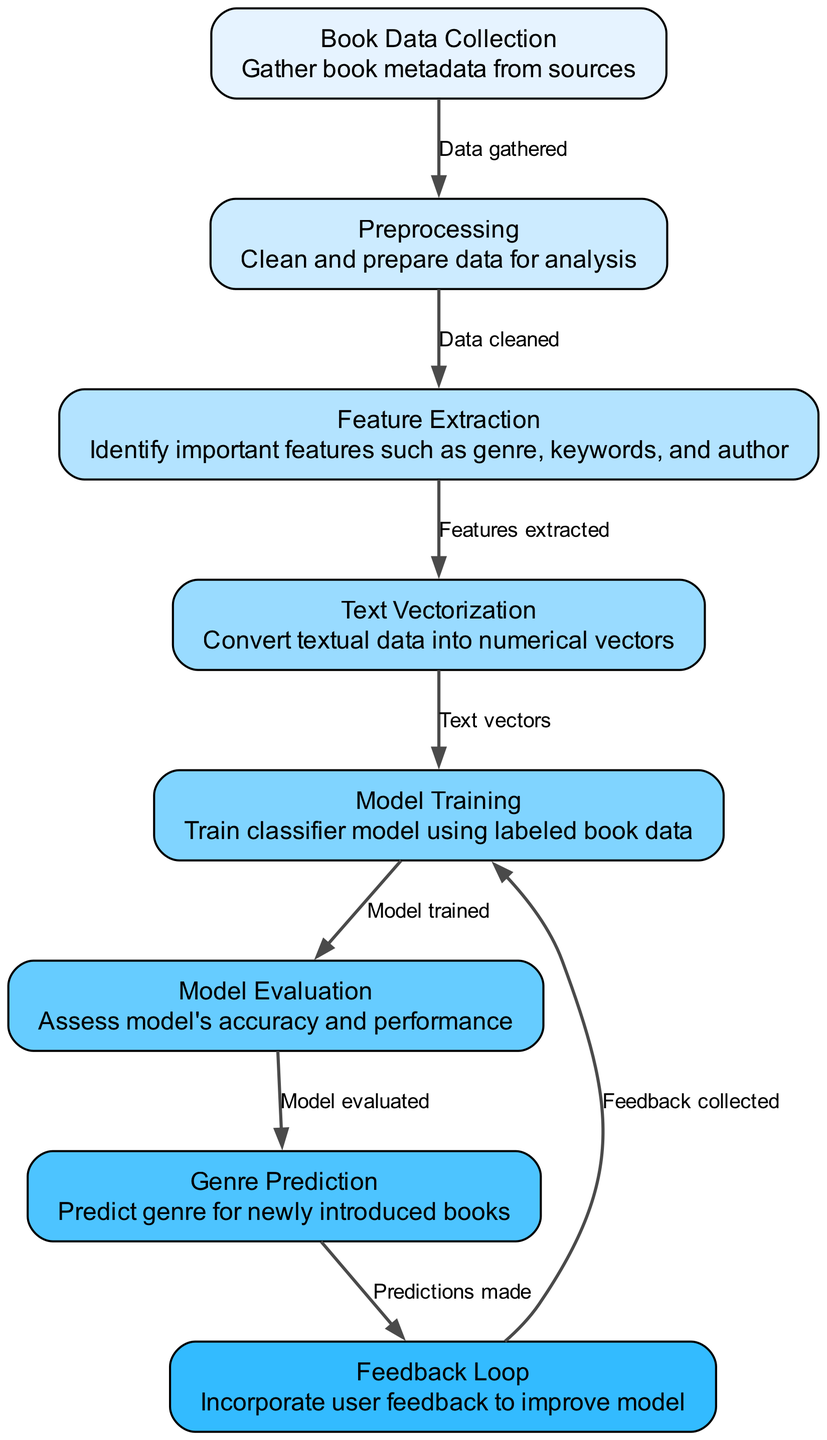What is the first node in the diagram? The first node is labeled "Book Data Collection," which is indicated in the diagram as the starting point of the process.
Answer: Book Data Collection How many nodes are in the diagram? By counting the nodes listed in the data, there are a total of 8 nodes present.
Answer: 8 What label is associated with the node that performs "Text Vectorization"? The label for the node that handles "Text Vectorization" is explicitly given as such in the diagram, corresponding to node ID 4.
Answer: Text Vectorization What task occurs after "Model Training"? The task that follows "Model Training" is "Model Evaluation," which is reflected as the next step after training the classifier model in the flow of the diagram.
Answer: Model Evaluation What is the relationship between "Genre Prediction" and "Feedback Loop"? The edge indicates that "Genre Prediction" leads directly to "Feedback Loop," showing that after predicting genres for new books, feedback is collected to enhance the model.
Answer: Predictions made What does the "Feature Extraction" process identify? The process of "Feature Extraction" identifies important features such as genre, keywords, and author, as described in its node label.
Answer: Important features What is the role of the "Feedback Loop" in this process? The role of the "Feedback Loop" is to incorporate user feedback to improve the model, connecting back to "Model Training," indicating an iterative process.
Answer: Improve model What does the "Text Vectorization" process convert? The "Text Vectorization" process converts textual data into numerical vectors, enabling machine learning algorithms to process the data effectively.
Answer: Textual data What sequence follows "Preprocessing"? After "Preprocessing," the sequence leads to "Feature Extraction," which means that once the data is cleaned, it is prepared for identifying key features.
Answer: Feature Extraction 